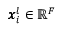Convert formula to latex. <formula><loc_0><loc_0><loc_500><loc_500>\pm b { x } _ { i } ^ { l } \in \mathbb { R } ^ { F }</formula> 